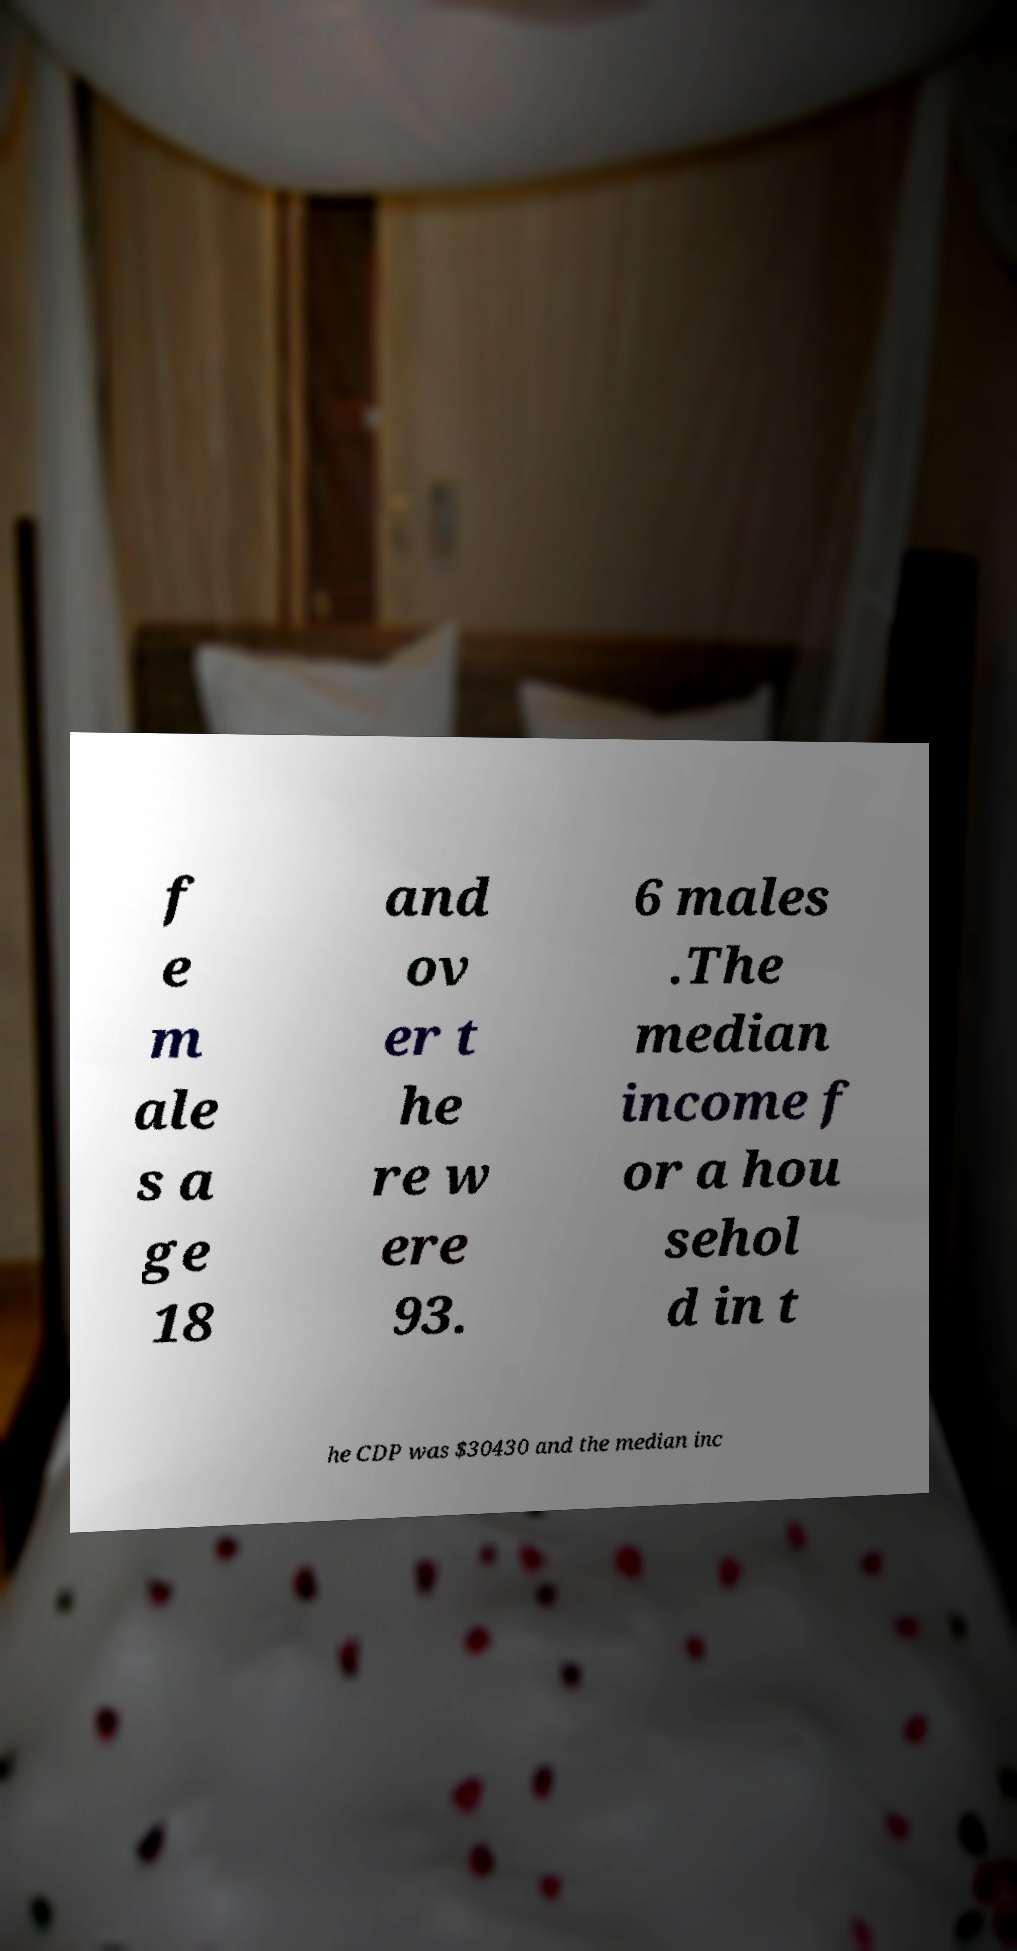Could you extract and type out the text from this image? f e m ale s a ge 18 and ov er t he re w ere 93. 6 males .The median income f or a hou sehol d in t he CDP was $30430 and the median inc 